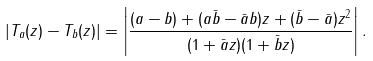<formula> <loc_0><loc_0><loc_500><loc_500>\left | T _ { a } ( z ) - T _ { b } ( z ) \right | = \left | \frac { ( a - b ) + ( a \bar { b } - \bar { a } b ) z + ( \bar { b } - \bar { a } ) z ^ { 2 } } { ( 1 + \bar { a } z ) ( 1 + \bar { b } z ) } \right | .</formula> 